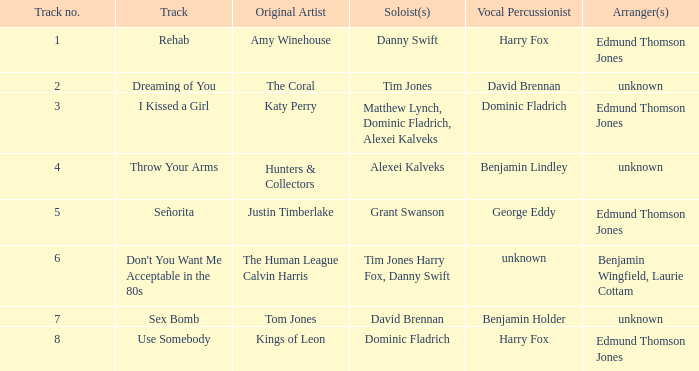Who is the drummer for the coral? David Brennan. 